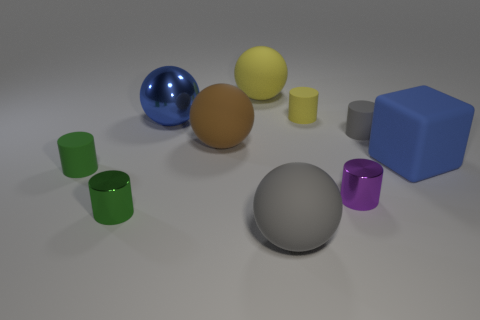Subtract all purple cylinders. How many cylinders are left? 4 Subtract all gray cubes. How many green cylinders are left? 2 Subtract all gray balls. How many balls are left? 3 Subtract 2 spheres. How many spheres are left? 2 Subtract 0 brown cubes. How many objects are left? 10 Subtract all cubes. How many objects are left? 9 Subtract all gray balls. Subtract all blue cubes. How many balls are left? 3 Subtract all tiny gray rubber objects. Subtract all gray cylinders. How many objects are left? 8 Add 7 green matte cylinders. How many green matte cylinders are left? 8 Add 3 large blue matte objects. How many large blue matte objects exist? 4 